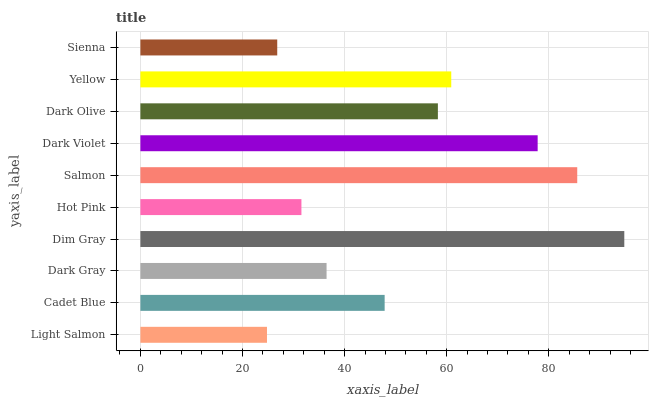Is Light Salmon the minimum?
Answer yes or no. Yes. Is Dim Gray the maximum?
Answer yes or no. Yes. Is Cadet Blue the minimum?
Answer yes or no. No. Is Cadet Blue the maximum?
Answer yes or no. No. Is Cadet Blue greater than Light Salmon?
Answer yes or no. Yes. Is Light Salmon less than Cadet Blue?
Answer yes or no. Yes. Is Light Salmon greater than Cadet Blue?
Answer yes or no. No. Is Cadet Blue less than Light Salmon?
Answer yes or no. No. Is Dark Olive the high median?
Answer yes or no. Yes. Is Cadet Blue the low median?
Answer yes or no. Yes. Is Yellow the high median?
Answer yes or no. No. Is Salmon the low median?
Answer yes or no. No. 